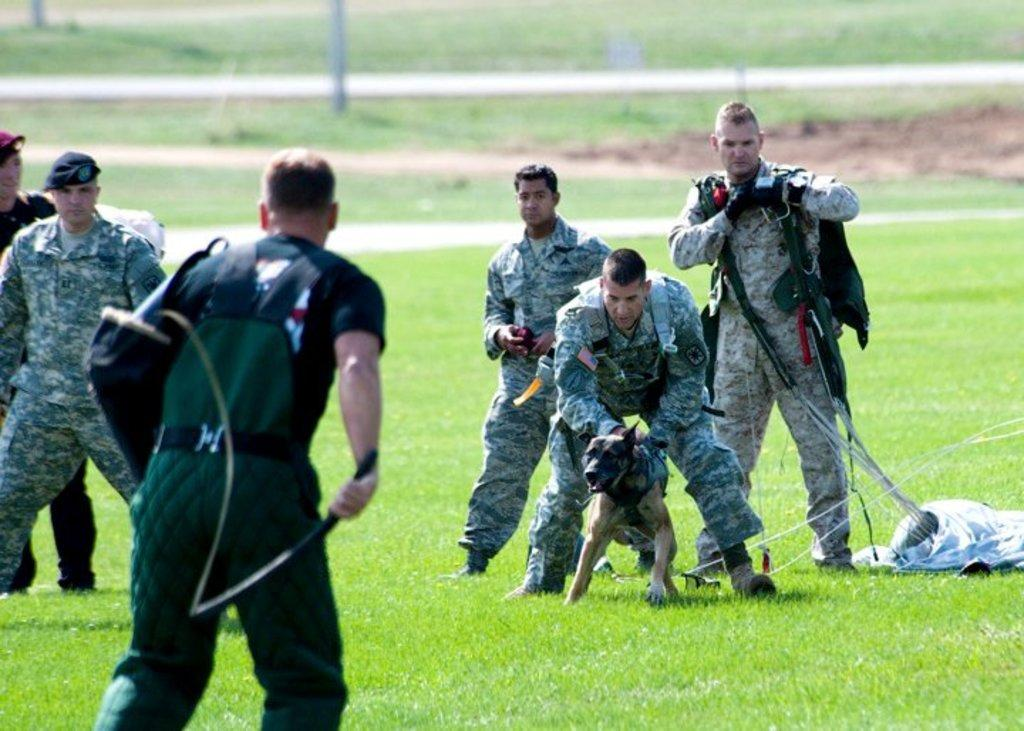What is happening in the image involving a group of people? There is a group of people standing in the image. Can you describe the interaction between a person and an animal in the image? There is a person holding a dog in the image. What type of terrain is visible in the image? There is grass visible in the image. How would you describe the background of the image? The background of the image is blurred. How many beggars can be seen in the image? There are no beggars present in the image. What type of board is being used by the group in the image? There is no board present in the image. 